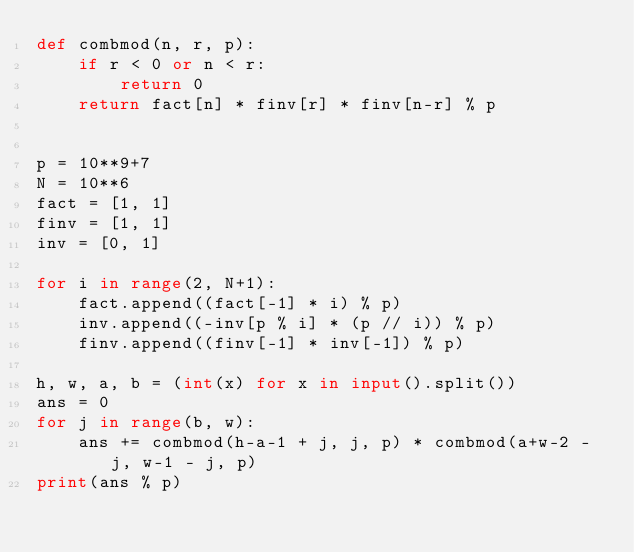<code> <loc_0><loc_0><loc_500><loc_500><_Python_>def combmod(n, r, p):
    if r < 0 or n < r:
        return 0
    return fact[n] * finv[r] * finv[n-r] % p


p = 10**9+7
N = 10**6
fact = [1, 1]
finv = [1, 1]
inv = [0, 1]

for i in range(2, N+1):
    fact.append((fact[-1] * i) % p)
    inv.append((-inv[p % i] * (p // i)) % p)
    finv.append((finv[-1] * inv[-1]) % p)

h, w, a, b = (int(x) for x in input().split())
ans = 0
for j in range(b, w):
    ans += combmod(h-a-1 + j, j, p) * combmod(a+w-2 - j, w-1 - j, p)
print(ans % p)
</code> 